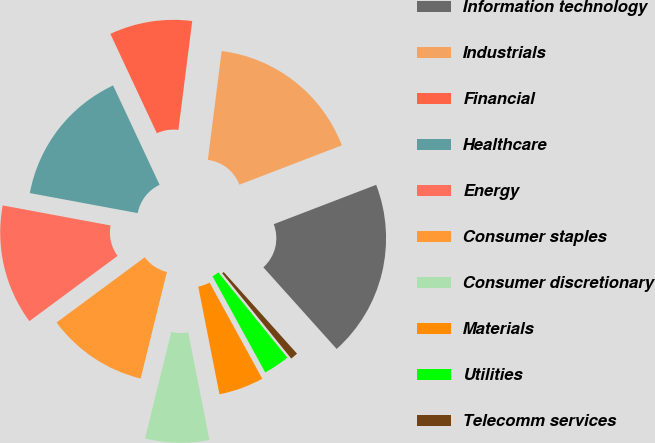Convert chart. <chart><loc_0><loc_0><loc_500><loc_500><pie_chart><fcel>Information technology<fcel>Industrials<fcel>Financial<fcel>Healthcare<fcel>Energy<fcel>Consumer staples<fcel>Consumer discretionary<fcel>Materials<fcel>Utilities<fcel>Telecomm services<nl><fcel>19.19%<fcel>17.15%<fcel>8.98%<fcel>15.11%<fcel>13.06%<fcel>11.02%<fcel>6.94%<fcel>4.89%<fcel>2.85%<fcel>0.81%<nl></chart> 